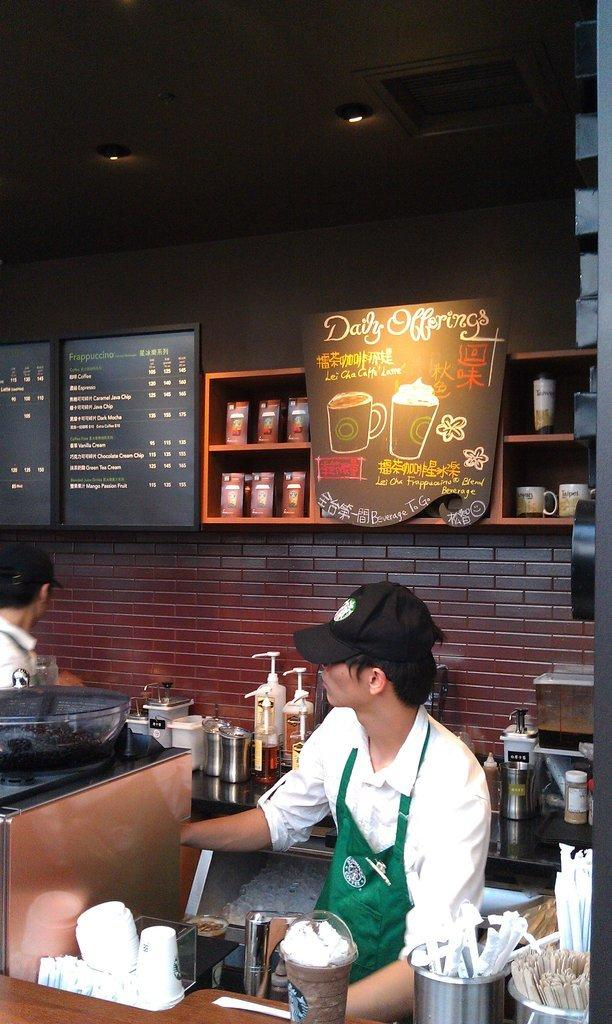<image>
Share a concise interpretation of the image provided. An employee at a coffee shop is standing on front of a display describing the Daily Offerings. 